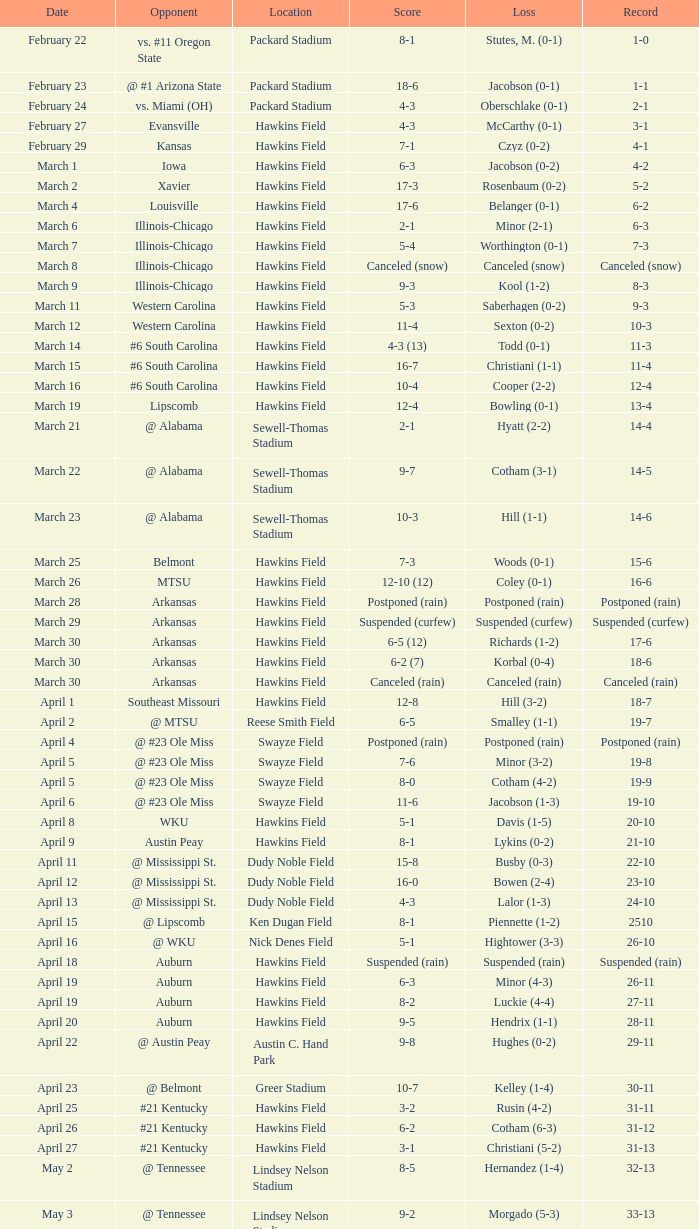What was the location of the game when the record was 2-1? Packard Stadium. Would you mind parsing the complete table? {'header': ['Date', 'Opponent', 'Location', 'Score', 'Loss', 'Record'], 'rows': [['February 22', 'vs. #11 Oregon State', 'Packard Stadium', '8-1', 'Stutes, M. (0-1)', '1-0'], ['February 23', '@ #1 Arizona State', 'Packard Stadium', '18-6', 'Jacobson (0-1)', '1-1'], ['February 24', 'vs. Miami (OH)', 'Packard Stadium', '4-3', 'Oberschlake (0-1)', '2-1'], ['February 27', 'Evansville', 'Hawkins Field', '4-3', 'McCarthy (0-1)', '3-1'], ['February 29', 'Kansas', 'Hawkins Field', '7-1', 'Czyz (0-2)', '4-1'], ['March 1', 'Iowa', 'Hawkins Field', '6-3', 'Jacobson (0-2)', '4-2'], ['March 2', 'Xavier', 'Hawkins Field', '17-3', 'Rosenbaum (0-2)', '5-2'], ['March 4', 'Louisville', 'Hawkins Field', '17-6', 'Belanger (0-1)', '6-2'], ['March 6', 'Illinois-Chicago', 'Hawkins Field', '2-1', 'Minor (2-1)', '6-3'], ['March 7', 'Illinois-Chicago', 'Hawkins Field', '5-4', 'Worthington (0-1)', '7-3'], ['March 8', 'Illinois-Chicago', 'Hawkins Field', 'Canceled (snow)', 'Canceled (snow)', 'Canceled (snow)'], ['March 9', 'Illinois-Chicago', 'Hawkins Field', '9-3', 'Kool (1-2)', '8-3'], ['March 11', 'Western Carolina', 'Hawkins Field', '5-3', 'Saberhagen (0-2)', '9-3'], ['March 12', 'Western Carolina', 'Hawkins Field', '11-4', 'Sexton (0-2)', '10-3'], ['March 14', '#6 South Carolina', 'Hawkins Field', '4-3 (13)', 'Todd (0-1)', '11-3'], ['March 15', '#6 South Carolina', 'Hawkins Field', '16-7', 'Christiani (1-1)', '11-4'], ['March 16', '#6 South Carolina', 'Hawkins Field', '10-4', 'Cooper (2-2)', '12-4'], ['March 19', 'Lipscomb', 'Hawkins Field', '12-4', 'Bowling (0-1)', '13-4'], ['March 21', '@ Alabama', 'Sewell-Thomas Stadium', '2-1', 'Hyatt (2-2)', '14-4'], ['March 22', '@ Alabama', 'Sewell-Thomas Stadium', '9-7', 'Cotham (3-1)', '14-5'], ['March 23', '@ Alabama', 'Sewell-Thomas Stadium', '10-3', 'Hill (1-1)', '14-6'], ['March 25', 'Belmont', 'Hawkins Field', '7-3', 'Woods (0-1)', '15-6'], ['March 26', 'MTSU', 'Hawkins Field', '12-10 (12)', 'Coley (0-1)', '16-6'], ['March 28', 'Arkansas', 'Hawkins Field', 'Postponed (rain)', 'Postponed (rain)', 'Postponed (rain)'], ['March 29', 'Arkansas', 'Hawkins Field', 'Suspended (curfew)', 'Suspended (curfew)', 'Suspended (curfew)'], ['March 30', 'Arkansas', 'Hawkins Field', '6-5 (12)', 'Richards (1-2)', '17-6'], ['March 30', 'Arkansas', 'Hawkins Field', '6-2 (7)', 'Korbal (0-4)', '18-6'], ['March 30', 'Arkansas', 'Hawkins Field', 'Canceled (rain)', 'Canceled (rain)', 'Canceled (rain)'], ['April 1', 'Southeast Missouri', 'Hawkins Field', '12-8', 'Hill (3-2)', '18-7'], ['April 2', '@ MTSU', 'Reese Smith Field', '6-5', 'Smalley (1-1)', '19-7'], ['April 4', '@ #23 Ole Miss', 'Swayze Field', 'Postponed (rain)', 'Postponed (rain)', 'Postponed (rain)'], ['April 5', '@ #23 Ole Miss', 'Swayze Field', '7-6', 'Minor (3-2)', '19-8'], ['April 5', '@ #23 Ole Miss', 'Swayze Field', '8-0', 'Cotham (4-2)', '19-9'], ['April 6', '@ #23 Ole Miss', 'Swayze Field', '11-6', 'Jacobson (1-3)', '19-10'], ['April 8', 'WKU', 'Hawkins Field', '5-1', 'Davis (1-5)', '20-10'], ['April 9', 'Austin Peay', 'Hawkins Field', '8-1', 'Lykins (0-2)', '21-10'], ['April 11', '@ Mississippi St.', 'Dudy Noble Field', '15-8', 'Busby (0-3)', '22-10'], ['April 12', '@ Mississippi St.', 'Dudy Noble Field', '16-0', 'Bowen (2-4)', '23-10'], ['April 13', '@ Mississippi St.', 'Dudy Noble Field', '4-3', 'Lalor (1-3)', '24-10'], ['April 15', '@ Lipscomb', 'Ken Dugan Field', '8-1', 'Piennette (1-2)', '2510'], ['April 16', '@ WKU', 'Nick Denes Field', '5-1', 'Hightower (3-3)', '26-10'], ['April 18', 'Auburn', 'Hawkins Field', 'Suspended (rain)', 'Suspended (rain)', 'Suspended (rain)'], ['April 19', 'Auburn', 'Hawkins Field', '6-3', 'Minor (4-3)', '26-11'], ['April 19', 'Auburn', 'Hawkins Field', '8-2', 'Luckie (4-4)', '27-11'], ['April 20', 'Auburn', 'Hawkins Field', '9-5', 'Hendrix (1-1)', '28-11'], ['April 22', '@ Austin Peay', 'Austin C. Hand Park', '9-8', 'Hughes (0-2)', '29-11'], ['April 23', '@ Belmont', 'Greer Stadium', '10-7', 'Kelley (1-4)', '30-11'], ['April 25', '#21 Kentucky', 'Hawkins Field', '3-2', 'Rusin (4-2)', '31-11'], ['April 26', '#21 Kentucky', 'Hawkins Field', '6-2', 'Cotham (6-3)', '31-12'], ['April 27', '#21 Kentucky', 'Hawkins Field', '3-1', 'Christiani (5-2)', '31-13'], ['May 2', '@ Tennessee', 'Lindsey Nelson Stadium', '8-5', 'Hernandez (1-4)', '32-13'], ['May 3', '@ Tennessee', 'Lindsey Nelson Stadium', '9-2', 'Morgado (5-3)', '33-13'], ['May 4', '@ Tennessee', 'Lindsey Nelson Stadium', '10-8', 'Wiltz (3-2)', '34-13'], ['May 6', 'vs. Memphis', 'Pringles Park', '8-0', 'Martin (4-3)', '35-13'], ['May 7', 'Tennessee Tech', 'Hawkins Field', '7-2', 'Liberatore (1-1)', '36-13'], ['May 9', '#9 Georgia', 'Hawkins Field', '13-7', 'Holder (7-3)', '37-13'], ['May 10', '#9 Georgia', 'Hawkins Field', '4-2 (10)', 'Brewer (4-1)', '37-14'], ['May 11', '#9 Georgia', 'Hawkins Field', '12-10', 'Christiani (5-3)', '37-15'], ['May 15', '@ Florida', 'McKethan Stadium', '8-6', 'Brewer (4-2)', '37-16'], ['May 16', '@ Florida', 'McKethan Stadium', '5-4', 'Cotham (7-4)', '37-17'], ['May 17', '@ Florida', 'McKethan Stadium', '13-12 (11)', 'Jacobson (1-4)', '37-18']]} 